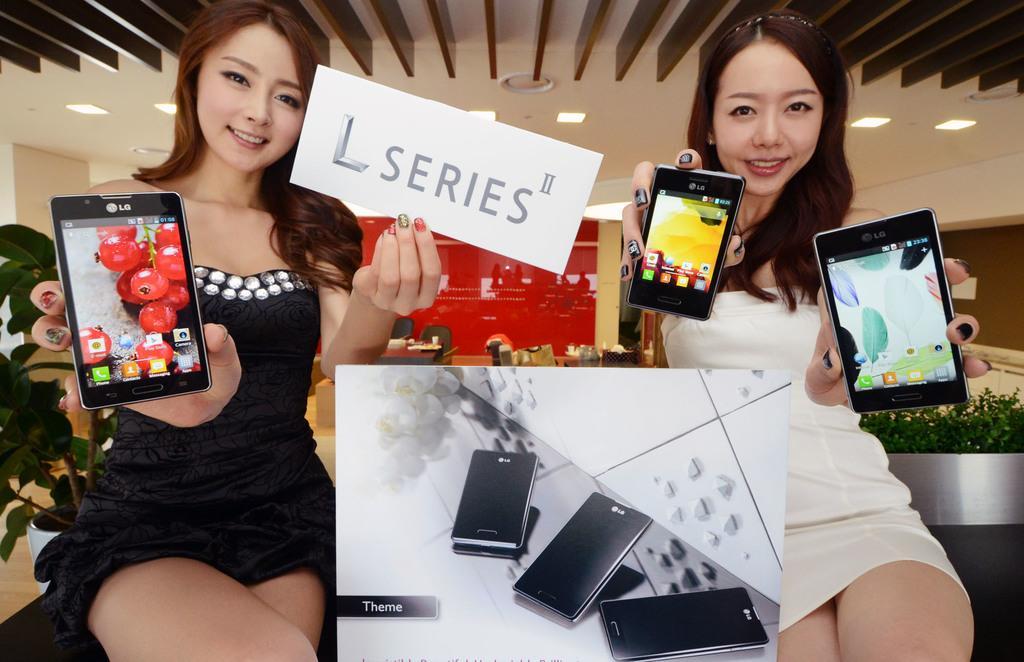Could you give a brief overview of what you see in this image? In this image i can see 2 women sitting, The woman on the left side is wearing a black dress and the woman on the right side is wearing a white dress. Both of them are holding cell phones in their hands. In the background i can see few plants, the ceiling and few lights to the ceiling. 